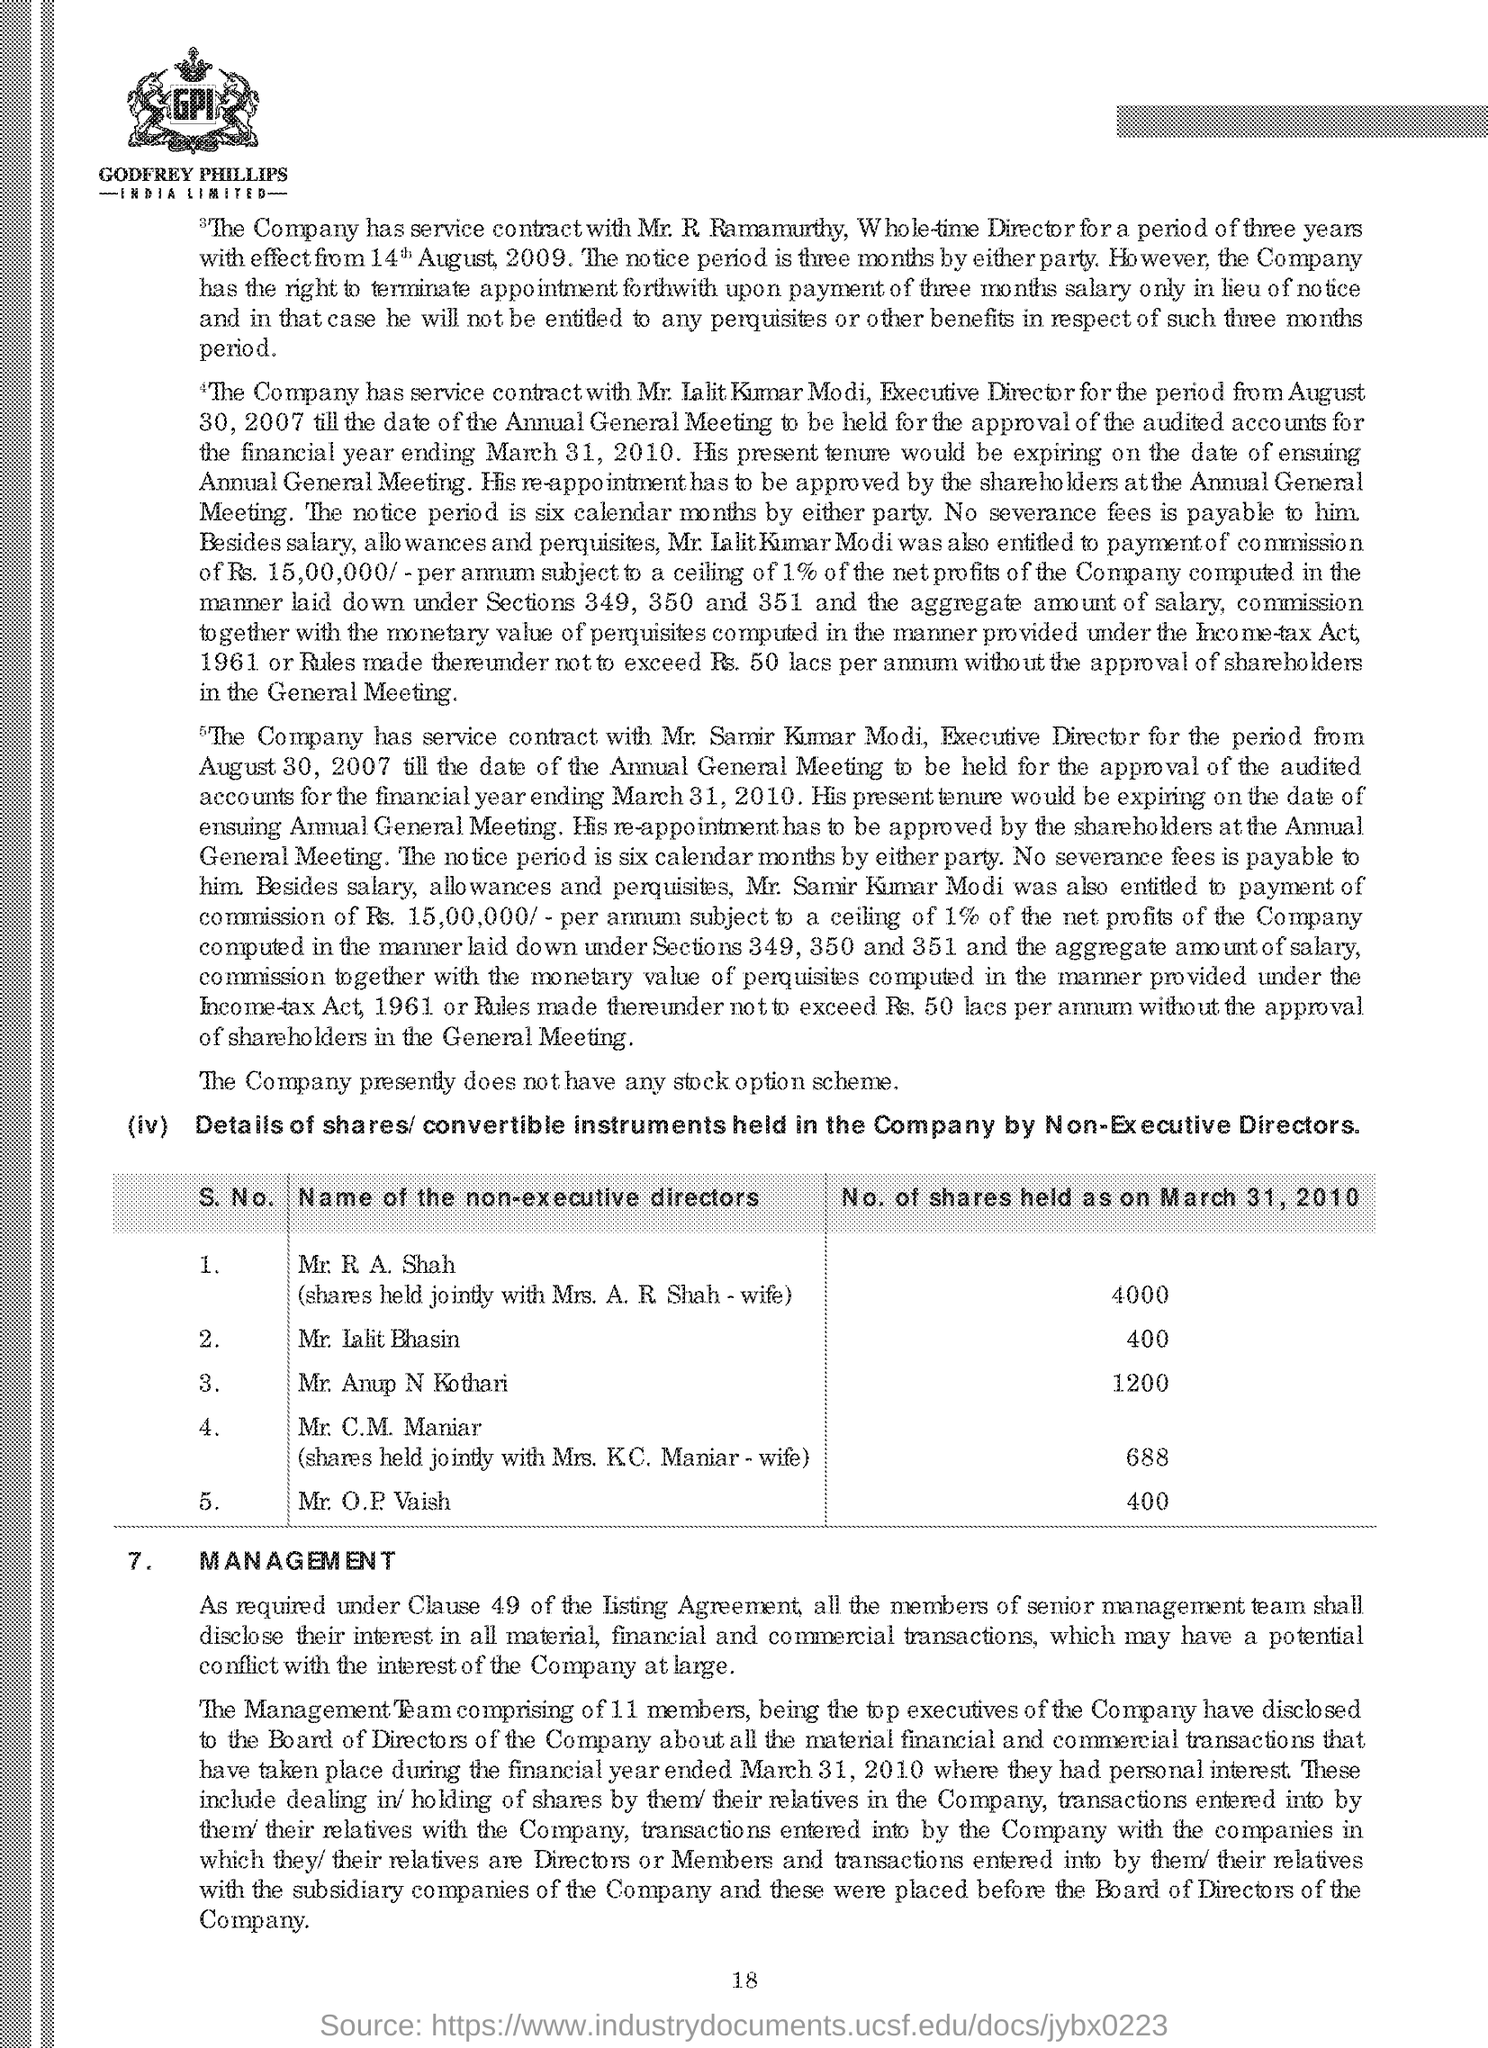What is the last title in the document?
Offer a terse response. Management. What is the Page Number?
Ensure brevity in your answer.  18. 